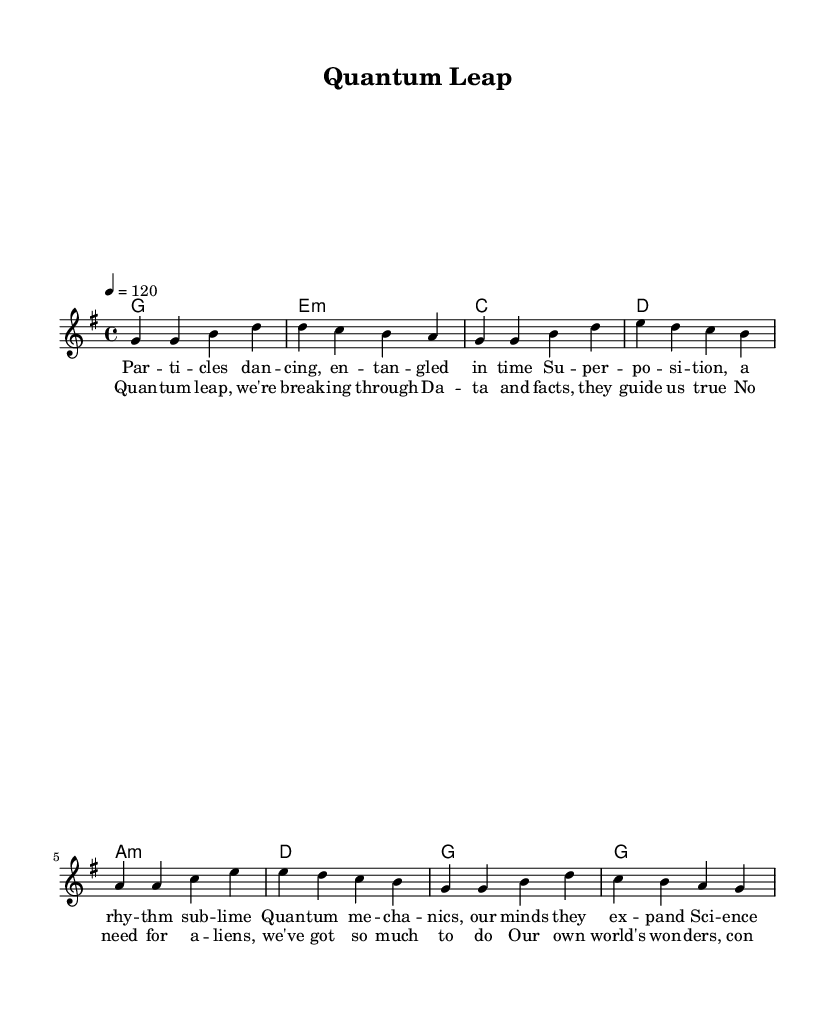What is the key signature of this music? The key signature is G major, which has one sharp (F#). The piece begins with the note G and uses the scale associated with this key signature throughout.
Answer: G major What is the time signature of this music? The time signature is 4/4, which means there are four beats in each measure and a quarter note receives one beat. This is evident from the 4/4 notation at the beginning of the piece.
Answer: 4/4 What is the tempo of this music? The tempo is 120 beats per minute, as indicated by the marking "4 = 120." This informs us about the speed of the piece.
Answer: 120 How many measures are there in the melody? To find the number of measures, we count each group of notes separated by the vertical lines (bar lines). The melody has eight measures in total.
Answer: 8 What is the primary theme of the lyrics? The lyrics focus on scientific concepts such as quantum mechanics, entanglement, and breakthroughs. The chorus emphasizes the power of data and facts, reflecting a theme of exploration.
Answer: Science How does the harmony support the melody in this piece? The harmony consists of chords that complement the melodic line, chosen from the G major scale. The use of major and minor chords reinforces the emotional context of the lyrics about scientific progress.
Answer: Complementary What unique K-Pop element can be identified in the song structure? The structure includes a clear verse and chorus section, typical of K-Pop songs where catchy phrases are repeated to enhance memorability and engagement. This format is prevalent in K-Pop to appeal to listeners.
Answer: Verse-Chorus 